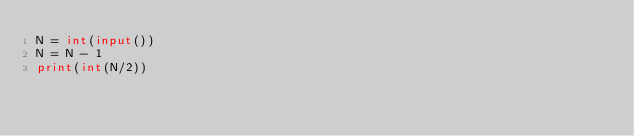<code> <loc_0><loc_0><loc_500><loc_500><_Python_>N = int(input())
N = N - 1
print(int(N/2))
</code> 